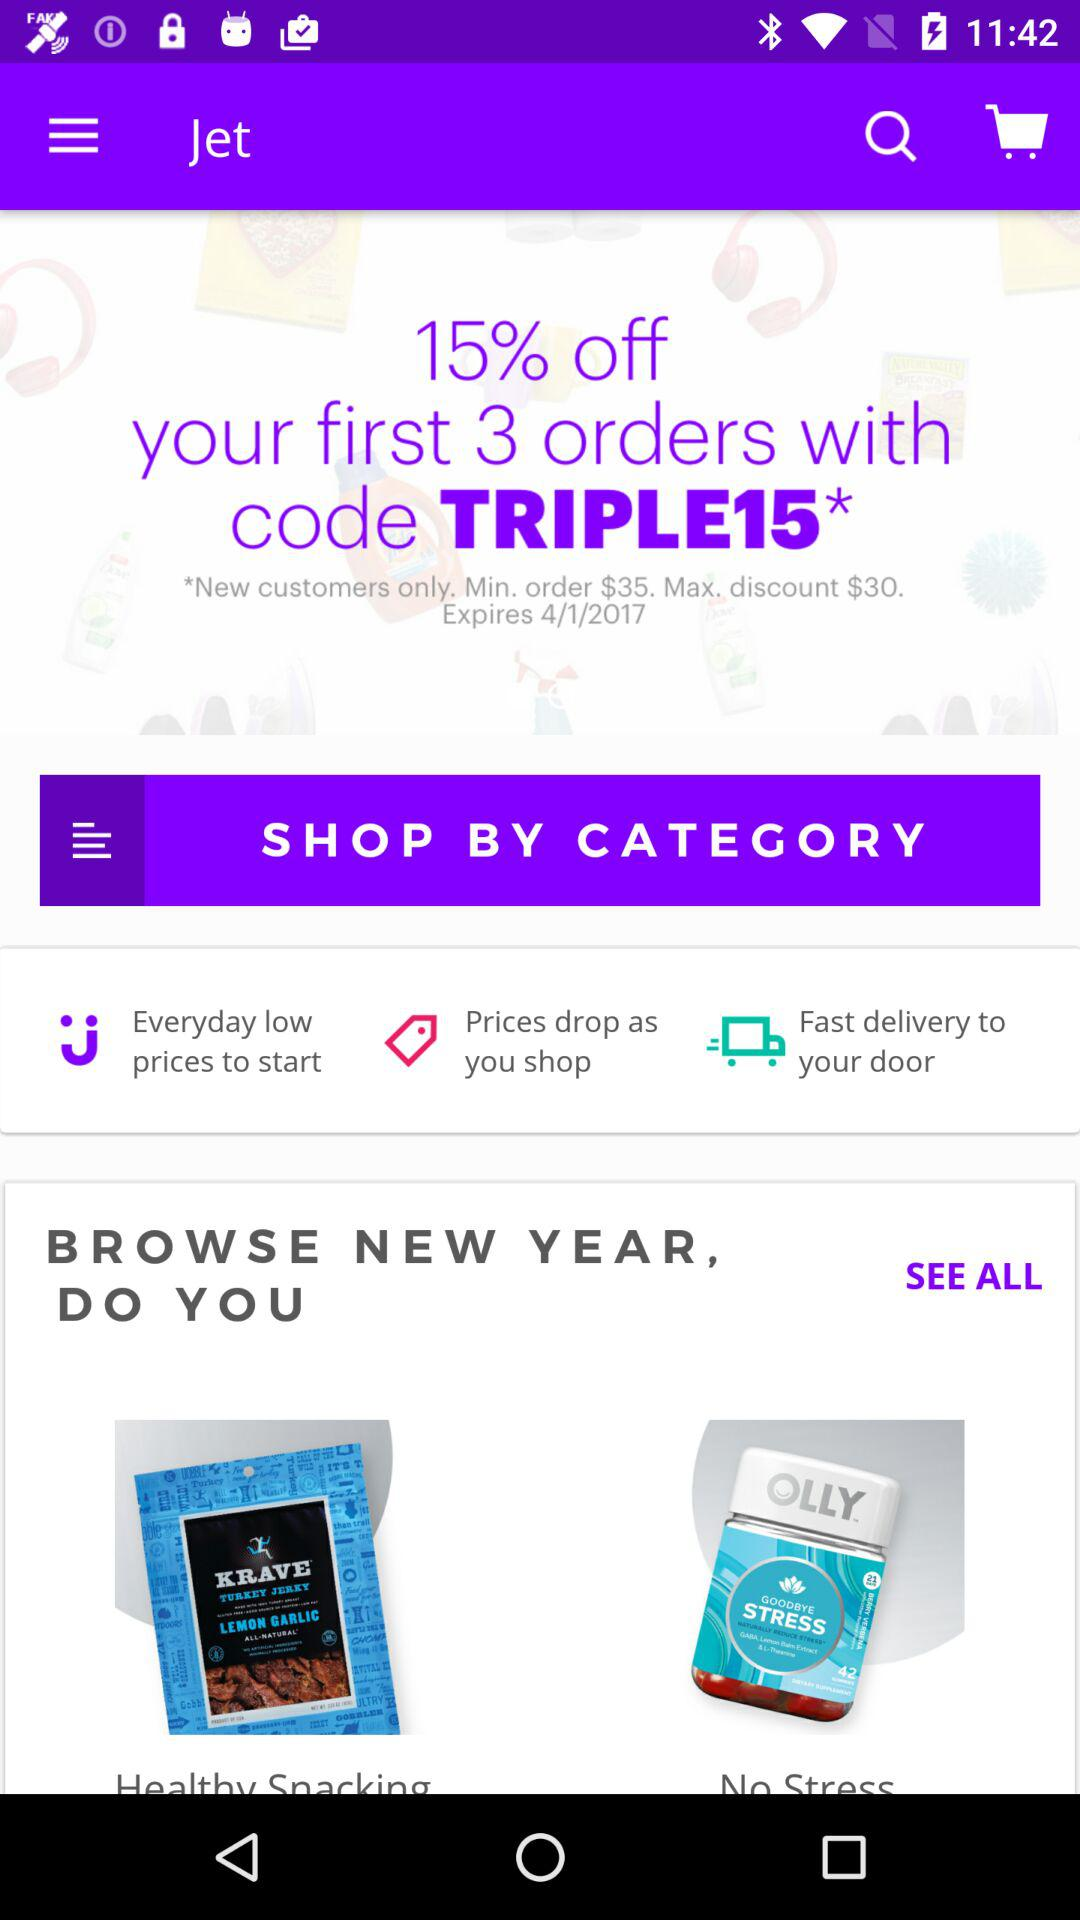What percentage is off on the first 3 orders? There is 15% off on the first 3 orders. 